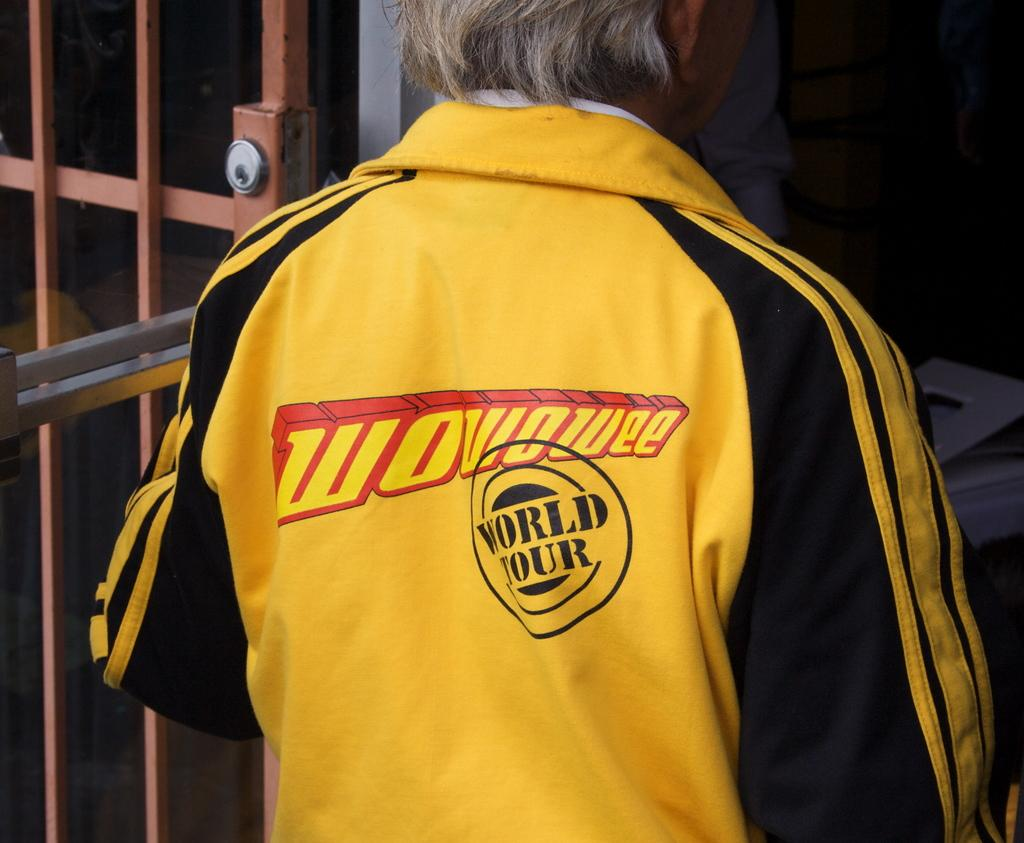Provide a one-sentence caption for the provided image. The back of man's yellow shirt reads "wowowee world tour.". 